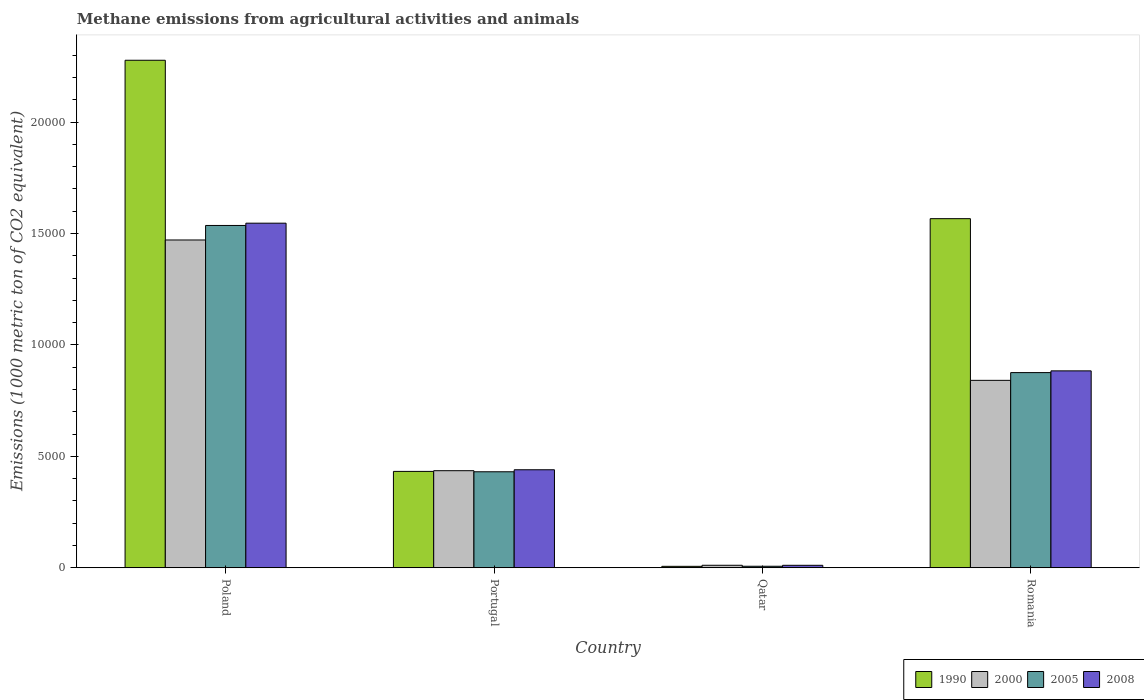How many different coloured bars are there?
Give a very brief answer. 4. How many groups of bars are there?
Provide a short and direct response. 4. Are the number of bars on each tick of the X-axis equal?
Offer a very short reply. Yes. How many bars are there on the 2nd tick from the left?
Make the answer very short. 4. How many bars are there on the 3rd tick from the right?
Your answer should be compact. 4. What is the label of the 2nd group of bars from the left?
Give a very brief answer. Portugal. What is the amount of methane emitted in 2008 in Portugal?
Provide a succinct answer. 4397.6. Across all countries, what is the maximum amount of methane emitted in 2008?
Ensure brevity in your answer.  1.55e+04. Across all countries, what is the minimum amount of methane emitted in 2000?
Your answer should be very brief. 111.5. In which country was the amount of methane emitted in 2005 maximum?
Ensure brevity in your answer.  Poland. In which country was the amount of methane emitted in 2000 minimum?
Your answer should be very brief. Qatar. What is the total amount of methane emitted in 1990 in the graph?
Make the answer very short. 4.28e+04. What is the difference between the amount of methane emitted in 1990 in Poland and that in Romania?
Your response must be concise. 7108.8. What is the difference between the amount of methane emitted in 1990 in Portugal and the amount of methane emitted in 2008 in Poland?
Offer a terse response. -1.11e+04. What is the average amount of methane emitted in 1990 per country?
Keep it short and to the point. 1.07e+04. What is the difference between the amount of methane emitted of/in 2000 and amount of methane emitted of/in 2008 in Romania?
Your response must be concise. -425.4. In how many countries, is the amount of methane emitted in 2005 greater than 7000 1000 metric ton?
Provide a short and direct response. 2. What is the ratio of the amount of methane emitted in 2000 in Poland to that in Romania?
Give a very brief answer. 1.75. Is the amount of methane emitted in 2000 in Portugal less than that in Romania?
Offer a very short reply. Yes. What is the difference between the highest and the second highest amount of methane emitted in 2008?
Make the answer very short. 4437.1. What is the difference between the highest and the lowest amount of methane emitted in 2008?
Provide a short and direct response. 1.54e+04. Is the sum of the amount of methane emitted in 2005 in Poland and Qatar greater than the maximum amount of methane emitted in 1990 across all countries?
Make the answer very short. No. What does the 4th bar from the left in Poland represents?
Give a very brief answer. 2008. What does the 3rd bar from the right in Romania represents?
Your answer should be very brief. 2000. How many bars are there?
Your answer should be compact. 16. What is the difference between two consecutive major ticks on the Y-axis?
Your response must be concise. 5000. Does the graph contain grids?
Provide a succinct answer. No. What is the title of the graph?
Keep it short and to the point. Methane emissions from agricultural activities and animals. Does "2008" appear as one of the legend labels in the graph?
Keep it short and to the point. Yes. What is the label or title of the X-axis?
Give a very brief answer. Country. What is the label or title of the Y-axis?
Offer a very short reply. Emissions (1000 metric ton of CO2 equivalent). What is the Emissions (1000 metric ton of CO2 equivalent) of 1990 in Poland?
Your answer should be very brief. 2.28e+04. What is the Emissions (1000 metric ton of CO2 equivalent) in 2000 in Poland?
Your answer should be compact. 1.47e+04. What is the Emissions (1000 metric ton of CO2 equivalent) of 2005 in Poland?
Give a very brief answer. 1.54e+04. What is the Emissions (1000 metric ton of CO2 equivalent) in 2008 in Poland?
Provide a succinct answer. 1.55e+04. What is the Emissions (1000 metric ton of CO2 equivalent) in 1990 in Portugal?
Keep it short and to the point. 4324.1. What is the Emissions (1000 metric ton of CO2 equivalent) of 2000 in Portugal?
Offer a very short reply. 4355.4. What is the Emissions (1000 metric ton of CO2 equivalent) in 2005 in Portugal?
Offer a terse response. 4307.2. What is the Emissions (1000 metric ton of CO2 equivalent) in 2008 in Portugal?
Give a very brief answer. 4397.6. What is the Emissions (1000 metric ton of CO2 equivalent) of 1990 in Qatar?
Give a very brief answer. 63.8. What is the Emissions (1000 metric ton of CO2 equivalent) in 2000 in Qatar?
Make the answer very short. 111.5. What is the Emissions (1000 metric ton of CO2 equivalent) in 2005 in Qatar?
Keep it short and to the point. 67.4. What is the Emissions (1000 metric ton of CO2 equivalent) of 2008 in Qatar?
Your answer should be very brief. 110. What is the Emissions (1000 metric ton of CO2 equivalent) in 1990 in Romania?
Offer a very short reply. 1.57e+04. What is the Emissions (1000 metric ton of CO2 equivalent) of 2000 in Romania?
Offer a very short reply. 8409.3. What is the Emissions (1000 metric ton of CO2 equivalent) in 2005 in Romania?
Provide a short and direct response. 8756.8. What is the Emissions (1000 metric ton of CO2 equivalent) in 2008 in Romania?
Offer a very short reply. 8834.7. Across all countries, what is the maximum Emissions (1000 metric ton of CO2 equivalent) of 1990?
Ensure brevity in your answer.  2.28e+04. Across all countries, what is the maximum Emissions (1000 metric ton of CO2 equivalent) in 2000?
Your response must be concise. 1.47e+04. Across all countries, what is the maximum Emissions (1000 metric ton of CO2 equivalent) in 2005?
Your answer should be compact. 1.54e+04. Across all countries, what is the maximum Emissions (1000 metric ton of CO2 equivalent) of 2008?
Your answer should be very brief. 1.55e+04. Across all countries, what is the minimum Emissions (1000 metric ton of CO2 equivalent) in 1990?
Offer a terse response. 63.8. Across all countries, what is the minimum Emissions (1000 metric ton of CO2 equivalent) in 2000?
Give a very brief answer. 111.5. Across all countries, what is the minimum Emissions (1000 metric ton of CO2 equivalent) in 2005?
Your answer should be very brief. 67.4. Across all countries, what is the minimum Emissions (1000 metric ton of CO2 equivalent) in 2008?
Ensure brevity in your answer.  110. What is the total Emissions (1000 metric ton of CO2 equivalent) of 1990 in the graph?
Provide a succinct answer. 4.28e+04. What is the total Emissions (1000 metric ton of CO2 equivalent) in 2000 in the graph?
Provide a succinct answer. 2.76e+04. What is the total Emissions (1000 metric ton of CO2 equivalent) in 2005 in the graph?
Offer a terse response. 2.85e+04. What is the total Emissions (1000 metric ton of CO2 equivalent) of 2008 in the graph?
Make the answer very short. 2.88e+04. What is the difference between the Emissions (1000 metric ton of CO2 equivalent) of 1990 in Poland and that in Portugal?
Your response must be concise. 1.84e+04. What is the difference between the Emissions (1000 metric ton of CO2 equivalent) of 2000 in Poland and that in Portugal?
Keep it short and to the point. 1.04e+04. What is the difference between the Emissions (1000 metric ton of CO2 equivalent) in 2005 in Poland and that in Portugal?
Make the answer very short. 1.11e+04. What is the difference between the Emissions (1000 metric ton of CO2 equivalent) in 2008 in Poland and that in Portugal?
Your answer should be compact. 1.11e+04. What is the difference between the Emissions (1000 metric ton of CO2 equivalent) of 1990 in Poland and that in Qatar?
Keep it short and to the point. 2.27e+04. What is the difference between the Emissions (1000 metric ton of CO2 equivalent) in 2000 in Poland and that in Qatar?
Give a very brief answer. 1.46e+04. What is the difference between the Emissions (1000 metric ton of CO2 equivalent) of 2005 in Poland and that in Qatar?
Make the answer very short. 1.53e+04. What is the difference between the Emissions (1000 metric ton of CO2 equivalent) in 2008 in Poland and that in Qatar?
Your answer should be very brief. 1.54e+04. What is the difference between the Emissions (1000 metric ton of CO2 equivalent) of 1990 in Poland and that in Romania?
Make the answer very short. 7108.8. What is the difference between the Emissions (1000 metric ton of CO2 equivalent) in 2000 in Poland and that in Romania?
Your response must be concise. 6299.2. What is the difference between the Emissions (1000 metric ton of CO2 equivalent) in 2005 in Poland and that in Romania?
Offer a very short reply. 6603. What is the difference between the Emissions (1000 metric ton of CO2 equivalent) in 2008 in Poland and that in Romania?
Offer a terse response. 6627.7. What is the difference between the Emissions (1000 metric ton of CO2 equivalent) in 1990 in Portugal and that in Qatar?
Provide a succinct answer. 4260.3. What is the difference between the Emissions (1000 metric ton of CO2 equivalent) of 2000 in Portugal and that in Qatar?
Your response must be concise. 4243.9. What is the difference between the Emissions (1000 metric ton of CO2 equivalent) of 2005 in Portugal and that in Qatar?
Give a very brief answer. 4239.8. What is the difference between the Emissions (1000 metric ton of CO2 equivalent) in 2008 in Portugal and that in Qatar?
Make the answer very short. 4287.6. What is the difference between the Emissions (1000 metric ton of CO2 equivalent) of 1990 in Portugal and that in Romania?
Provide a short and direct response. -1.13e+04. What is the difference between the Emissions (1000 metric ton of CO2 equivalent) of 2000 in Portugal and that in Romania?
Make the answer very short. -4053.9. What is the difference between the Emissions (1000 metric ton of CO2 equivalent) in 2005 in Portugal and that in Romania?
Ensure brevity in your answer.  -4449.6. What is the difference between the Emissions (1000 metric ton of CO2 equivalent) of 2008 in Portugal and that in Romania?
Your response must be concise. -4437.1. What is the difference between the Emissions (1000 metric ton of CO2 equivalent) in 1990 in Qatar and that in Romania?
Offer a very short reply. -1.56e+04. What is the difference between the Emissions (1000 metric ton of CO2 equivalent) of 2000 in Qatar and that in Romania?
Provide a short and direct response. -8297.8. What is the difference between the Emissions (1000 metric ton of CO2 equivalent) in 2005 in Qatar and that in Romania?
Your response must be concise. -8689.4. What is the difference between the Emissions (1000 metric ton of CO2 equivalent) in 2008 in Qatar and that in Romania?
Ensure brevity in your answer.  -8724.7. What is the difference between the Emissions (1000 metric ton of CO2 equivalent) of 1990 in Poland and the Emissions (1000 metric ton of CO2 equivalent) of 2000 in Portugal?
Make the answer very short. 1.84e+04. What is the difference between the Emissions (1000 metric ton of CO2 equivalent) of 1990 in Poland and the Emissions (1000 metric ton of CO2 equivalent) of 2005 in Portugal?
Ensure brevity in your answer.  1.85e+04. What is the difference between the Emissions (1000 metric ton of CO2 equivalent) in 1990 in Poland and the Emissions (1000 metric ton of CO2 equivalent) in 2008 in Portugal?
Make the answer very short. 1.84e+04. What is the difference between the Emissions (1000 metric ton of CO2 equivalent) of 2000 in Poland and the Emissions (1000 metric ton of CO2 equivalent) of 2005 in Portugal?
Offer a very short reply. 1.04e+04. What is the difference between the Emissions (1000 metric ton of CO2 equivalent) of 2000 in Poland and the Emissions (1000 metric ton of CO2 equivalent) of 2008 in Portugal?
Your answer should be compact. 1.03e+04. What is the difference between the Emissions (1000 metric ton of CO2 equivalent) in 2005 in Poland and the Emissions (1000 metric ton of CO2 equivalent) in 2008 in Portugal?
Offer a terse response. 1.10e+04. What is the difference between the Emissions (1000 metric ton of CO2 equivalent) of 1990 in Poland and the Emissions (1000 metric ton of CO2 equivalent) of 2000 in Qatar?
Your answer should be compact. 2.27e+04. What is the difference between the Emissions (1000 metric ton of CO2 equivalent) in 1990 in Poland and the Emissions (1000 metric ton of CO2 equivalent) in 2005 in Qatar?
Provide a succinct answer. 2.27e+04. What is the difference between the Emissions (1000 metric ton of CO2 equivalent) in 1990 in Poland and the Emissions (1000 metric ton of CO2 equivalent) in 2008 in Qatar?
Your answer should be compact. 2.27e+04. What is the difference between the Emissions (1000 metric ton of CO2 equivalent) in 2000 in Poland and the Emissions (1000 metric ton of CO2 equivalent) in 2005 in Qatar?
Ensure brevity in your answer.  1.46e+04. What is the difference between the Emissions (1000 metric ton of CO2 equivalent) in 2000 in Poland and the Emissions (1000 metric ton of CO2 equivalent) in 2008 in Qatar?
Give a very brief answer. 1.46e+04. What is the difference between the Emissions (1000 metric ton of CO2 equivalent) in 2005 in Poland and the Emissions (1000 metric ton of CO2 equivalent) in 2008 in Qatar?
Provide a short and direct response. 1.52e+04. What is the difference between the Emissions (1000 metric ton of CO2 equivalent) in 1990 in Poland and the Emissions (1000 metric ton of CO2 equivalent) in 2000 in Romania?
Provide a succinct answer. 1.44e+04. What is the difference between the Emissions (1000 metric ton of CO2 equivalent) of 1990 in Poland and the Emissions (1000 metric ton of CO2 equivalent) of 2005 in Romania?
Offer a very short reply. 1.40e+04. What is the difference between the Emissions (1000 metric ton of CO2 equivalent) in 1990 in Poland and the Emissions (1000 metric ton of CO2 equivalent) in 2008 in Romania?
Ensure brevity in your answer.  1.39e+04. What is the difference between the Emissions (1000 metric ton of CO2 equivalent) in 2000 in Poland and the Emissions (1000 metric ton of CO2 equivalent) in 2005 in Romania?
Give a very brief answer. 5951.7. What is the difference between the Emissions (1000 metric ton of CO2 equivalent) of 2000 in Poland and the Emissions (1000 metric ton of CO2 equivalent) of 2008 in Romania?
Your response must be concise. 5873.8. What is the difference between the Emissions (1000 metric ton of CO2 equivalent) of 2005 in Poland and the Emissions (1000 metric ton of CO2 equivalent) of 2008 in Romania?
Your answer should be very brief. 6525.1. What is the difference between the Emissions (1000 metric ton of CO2 equivalent) in 1990 in Portugal and the Emissions (1000 metric ton of CO2 equivalent) in 2000 in Qatar?
Your response must be concise. 4212.6. What is the difference between the Emissions (1000 metric ton of CO2 equivalent) in 1990 in Portugal and the Emissions (1000 metric ton of CO2 equivalent) in 2005 in Qatar?
Your response must be concise. 4256.7. What is the difference between the Emissions (1000 metric ton of CO2 equivalent) in 1990 in Portugal and the Emissions (1000 metric ton of CO2 equivalent) in 2008 in Qatar?
Give a very brief answer. 4214.1. What is the difference between the Emissions (1000 metric ton of CO2 equivalent) in 2000 in Portugal and the Emissions (1000 metric ton of CO2 equivalent) in 2005 in Qatar?
Your answer should be compact. 4288. What is the difference between the Emissions (1000 metric ton of CO2 equivalent) in 2000 in Portugal and the Emissions (1000 metric ton of CO2 equivalent) in 2008 in Qatar?
Offer a very short reply. 4245.4. What is the difference between the Emissions (1000 metric ton of CO2 equivalent) of 2005 in Portugal and the Emissions (1000 metric ton of CO2 equivalent) of 2008 in Qatar?
Provide a short and direct response. 4197.2. What is the difference between the Emissions (1000 metric ton of CO2 equivalent) in 1990 in Portugal and the Emissions (1000 metric ton of CO2 equivalent) in 2000 in Romania?
Give a very brief answer. -4085.2. What is the difference between the Emissions (1000 metric ton of CO2 equivalent) in 1990 in Portugal and the Emissions (1000 metric ton of CO2 equivalent) in 2005 in Romania?
Your answer should be compact. -4432.7. What is the difference between the Emissions (1000 metric ton of CO2 equivalent) of 1990 in Portugal and the Emissions (1000 metric ton of CO2 equivalent) of 2008 in Romania?
Offer a very short reply. -4510.6. What is the difference between the Emissions (1000 metric ton of CO2 equivalent) of 2000 in Portugal and the Emissions (1000 metric ton of CO2 equivalent) of 2005 in Romania?
Offer a terse response. -4401.4. What is the difference between the Emissions (1000 metric ton of CO2 equivalent) in 2000 in Portugal and the Emissions (1000 metric ton of CO2 equivalent) in 2008 in Romania?
Your answer should be very brief. -4479.3. What is the difference between the Emissions (1000 metric ton of CO2 equivalent) of 2005 in Portugal and the Emissions (1000 metric ton of CO2 equivalent) of 2008 in Romania?
Offer a very short reply. -4527.5. What is the difference between the Emissions (1000 metric ton of CO2 equivalent) of 1990 in Qatar and the Emissions (1000 metric ton of CO2 equivalent) of 2000 in Romania?
Give a very brief answer. -8345.5. What is the difference between the Emissions (1000 metric ton of CO2 equivalent) in 1990 in Qatar and the Emissions (1000 metric ton of CO2 equivalent) in 2005 in Romania?
Offer a terse response. -8693. What is the difference between the Emissions (1000 metric ton of CO2 equivalent) in 1990 in Qatar and the Emissions (1000 metric ton of CO2 equivalent) in 2008 in Romania?
Provide a short and direct response. -8770.9. What is the difference between the Emissions (1000 metric ton of CO2 equivalent) of 2000 in Qatar and the Emissions (1000 metric ton of CO2 equivalent) of 2005 in Romania?
Keep it short and to the point. -8645.3. What is the difference between the Emissions (1000 metric ton of CO2 equivalent) of 2000 in Qatar and the Emissions (1000 metric ton of CO2 equivalent) of 2008 in Romania?
Provide a succinct answer. -8723.2. What is the difference between the Emissions (1000 metric ton of CO2 equivalent) in 2005 in Qatar and the Emissions (1000 metric ton of CO2 equivalent) in 2008 in Romania?
Provide a succinct answer. -8767.3. What is the average Emissions (1000 metric ton of CO2 equivalent) in 1990 per country?
Your answer should be very brief. 1.07e+04. What is the average Emissions (1000 metric ton of CO2 equivalent) in 2000 per country?
Provide a short and direct response. 6896.18. What is the average Emissions (1000 metric ton of CO2 equivalent) in 2005 per country?
Your answer should be very brief. 7122.8. What is the average Emissions (1000 metric ton of CO2 equivalent) in 2008 per country?
Provide a short and direct response. 7201.18. What is the difference between the Emissions (1000 metric ton of CO2 equivalent) of 1990 and Emissions (1000 metric ton of CO2 equivalent) of 2000 in Poland?
Give a very brief answer. 8065. What is the difference between the Emissions (1000 metric ton of CO2 equivalent) in 1990 and Emissions (1000 metric ton of CO2 equivalent) in 2005 in Poland?
Your answer should be very brief. 7413.7. What is the difference between the Emissions (1000 metric ton of CO2 equivalent) in 1990 and Emissions (1000 metric ton of CO2 equivalent) in 2008 in Poland?
Ensure brevity in your answer.  7311.1. What is the difference between the Emissions (1000 metric ton of CO2 equivalent) in 2000 and Emissions (1000 metric ton of CO2 equivalent) in 2005 in Poland?
Your response must be concise. -651.3. What is the difference between the Emissions (1000 metric ton of CO2 equivalent) of 2000 and Emissions (1000 metric ton of CO2 equivalent) of 2008 in Poland?
Offer a terse response. -753.9. What is the difference between the Emissions (1000 metric ton of CO2 equivalent) of 2005 and Emissions (1000 metric ton of CO2 equivalent) of 2008 in Poland?
Your answer should be compact. -102.6. What is the difference between the Emissions (1000 metric ton of CO2 equivalent) in 1990 and Emissions (1000 metric ton of CO2 equivalent) in 2000 in Portugal?
Offer a very short reply. -31.3. What is the difference between the Emissions (1000 metric ton of CO2 equivalent) of 1990 and Emissions (1000 metric ton of CO2 equivalent) of 2008 in Portugal?
Your answer should be compact. -73.5. What is the difference between the Emissions (1000 metric ton of CO2 equivalent) in 2000 and Emissions (1000 metric ton of CO2 equivalent) in 2005 in Portugal?
Your response must be concise. 48.2. What is the difference between the Emissions (1000 metric ton of CO2 equivalent) in 2000 and Emissions (1000 metric ton of CO2 equivalent) in 2008 in Portugal?
Keep it short and to the point. -42.2. What is the difference between the Emissions (1000 metric ton of CO2 equivalent) of 2005 and Emissions (1000 metric ton of CO2 equivalent) of 2008 in Portugal?
Keep it short and to the point. -90.4. What is the difference between the Emissions (1000 metric ton of CO2 equivalent) in 1990 and Emissions (1000 metric ton of CO2 equivalent) in 2000 in Qatar?
Offer a terse response. -47.7. What is the difference between the Emissions (1000 metric ton of CO2 equivalent) in 1990 and Emissions (1000 metric ton of CO2 equivalent) in 2005 in Qatar?
Keep it short and to the point. -3.6. What is the difference between the Emissions (1000 metric ton of CO2 equivalent) in 1990 and Emissions (1000 metric ton of CO2 equivalent) in 2008 in Qatar?
Offer a terse response. -46.2. What is the difference between the Emissions (1000 metric ton of CO2 equivalent) of 2000 and Emissions (1000 metric ton of CO2 equivalent) of 2005 in Qatar?
Give a very brief answer. 44.1. What is the difference between the Emissions (1000 metric ton of CO2 equivalent) in 2005 and Emissions (1000 metric ton of CO2 equivalent) in 2008 in Qatar?
Your answer should be very brief. -42.6. What is the difference between the Emissions (1000 metric ton of CO2 equivalent) of 1990 and Emissions (1000 metric ton of CO2 equivalent) of 2000 in Romania?
Ensure brevity in your answer.  7255.4. What is the difference between the Emissions (1000 metric ton of CO2 equivalent) of 1990 and Emissions (1000 metric ton of CO2 equivalent) of 2005 in Romania?
Provide a short and direct response. 6907.9. What is the difference between the Emissions (1000 metric ton of CO2 equivalent) of 1990 and Emissions (1000 metric ton of CO2 equivalent) of 2008 in Romania?
Your answer should be compact. 6830. What is the difference between the Emissions (1000 metric ton of CO2 equivalent) of 2000 and Emissions (1000 metric ton of CO2 equivalent) of 2005 in Romania?
Provide a succinct answer. -347.5. What is the difference between the Emissions (1000 metric ton of CO2 equivalent) in 2000 and Emissions (1000 metric ton of CO2 equivalent) in 2008 in Romania?
Provide a short and direct response. -425.4. What is the difference between the Emissions (1000 metric ton of CO2 equivalent) of 2005 and Emissions (1000 metric ton of CO2 equivalent) of 2008 in Romania?
Your answer should be very brief. -77.9. What is the ratio of the Emissions (1000 metric ton of CO2 equivalent) in 1990 in Poland to that in Portugal?
Provide a short and direct response. 5.27. What is the ratio of the Emissions (1000 metric ton of CO2 equivalent) in 2000 in Poland to that in Portugal?
Give a very brief answer. 3.38. What is the ratio of the Emissions (1000 metric ton of CO2 equivalent) in 2005 in Poland to that in Portugal?
Provide a succinct answer. 3.57. What is the ratio of the Emissions (1000 metric ton of CO2 equivalent) in 2008 in Poland to that in Portugal?
Make the answer very short. 3.52. What is the ratio of the Emissions (1000 metric ton of CO2 equivalent) of 1990 in Poland to that in Qatar?
Keep it short and to the point. 356.95. What is the ratio of the Emissions (1000 metric ton of CO2 equivalent) in 2000 in Poland to that in Qatar?
Your answer should be compact. 131.91. What is the ratio of the Emissions (1000 metric ton of CO2 equivalent) of 2005 in Poland to that in Qatar?
Give a very brief answer. 227.89. What is the ratio of the Emissions (1000 metric ton of CO2 equivalent) of 2008 in Poland to that in Qatar?
Your answer should be very brief. 140.57. What is the ratio of the Emissions (1000 metric ton of CO2 equivalent) in 1990 in Poland to that in Romania?
Your response must be concise. 1.45. What is the ratio of the Emissions (1000 metric ton of CO2 equivalent) of 2000 in Poland to that in Romania?
Your answer should be compact. 1.75. What is the ratio of the Emissions (1000 metric ton of CO2 equivalent) of 2005 in Poland to that in Romania?
Offer a terse response. 1.75. What is the ratio of the Emissions (1000 metric ton of CO2 equivalent) in 2008 in Poland to that in Romania?
Give a very brief answer. 1.75. What is the ratio of the Emissions (1000 metric ton of CO2 equivalent) of 1990 in Portugal to that in Qatar?
Your answer should be compact. 67.78. What is the ratio of the Emissions (1000 metric ton of CO2 equivalent) of 2000 in Portugal to that in Qatar?
Ensure brevity in your answer.  39.06. What is the ratio of the Emissions (1000 metric ton of CO2 equivalent) of 2005 in Portugal to that in Qatar?
Keep it short and to the point. 63.91. What is the ratio of the Emissions (1000 metric ton of CO2 equivalent) of 2008 in Portugal to that in Qatar?
Ensure brevity in your answer.  39.98. What is the ratio of the Emissions (1000 metric ton of CO2 equivalent) of 1990 in Portugal to that in Romania?
Offer a very short reply. 0.28. What is the ratio of the Emissions (1000 metric ton of CO2 equivalent) in 2000 in Portugal to that in Romania?
Offer a terse response. 0.52. What is the ratio of the Emissions (1000 metric ton of CO2 equivalent) in 2005 in Portugal to that in Romania?
Keep it short and to the point. 0.49. What is the ratio of the Emissions (1000 metric ton of CO2 equivalent) of 2008 in Portugal to that in Romania?
Give a very brief answer. 0.5. What is the ratio of the Emissions (1000 metric ton of CO2 equivalent) of 1990 in Qatar to that in Romania?
Provide a succinct answer. 0. What is the ratio of the Emissions (1000 metric ton of CO2 equivalent) in 2000 in Qatar to that in Romania?
Provide a short and direct response. 0.01. What is the ratio of the Emissions (1000 metric ton of CO2 equivalent) in 2005 in Qatar to that in Romania?
Your response must be concise. 0.01. What is the ratio of the Emissions (1000 metric ton of CO2 equivalent) of 2008 in Qatar to that in Romania?
Offer a terse response. 0.01. What is the difference between the highest and the second highest Emissions (1000 metric ton of CO2 equivalent) in 1990?
Keep it short and to the point. 7108.8. What is the difference between the highest and the second highest Emissions (1000 metric ton of CO2 equivalent) in 2000?
Give a very brief answer. 6299.2. What is the difference between the highest and the second highest Emissions (1000 metric ton of CO2 equivalent) of 2005?
Ensure brevity in your answer.  6603. What is the difference between the highest and the second highest Emissions (1000 metric ton of CO2 equivalent) of 2008?
Your answer should be compact. 6627.7. What is the difference between the highest and the lowest Emissions (1000 metric ton of CO2 equivalent) in 1990?
Offer a very short reply. 2.27e+04. What is the difference between the highest and the lowest Emissions (1000 metric ton of CO2 equivalent) of 2000?
Your answer should be compact. 1.46e+04. What is the difference between the highest and the lowest Emissions (1000 metric ton of CO2 equivalent) in 2005?
Your answer should be very brief. 1.53e+04. What is the difference between the highest and the lowest Emissions (1000 metric ton of CO2 equivalent) in 2008?
Keep it short and to the point. 1.54e+04. 